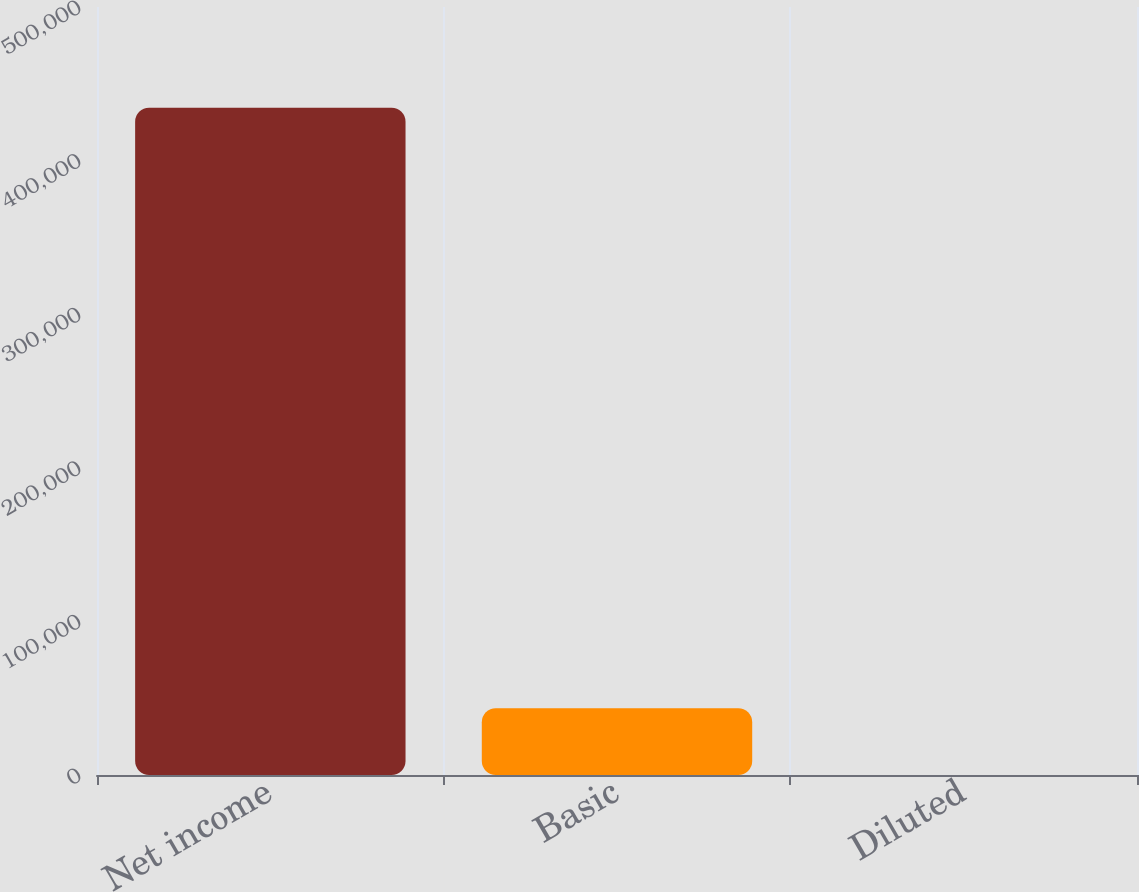<chart> <loc_0><loc_0><loc_500><loc_500><bar_chart><fcel>Net income<fcel>Basic<fcel>Diluted<nl><fcel>434405<fcel>43442.6<fcel>2.31<nl></chart> 